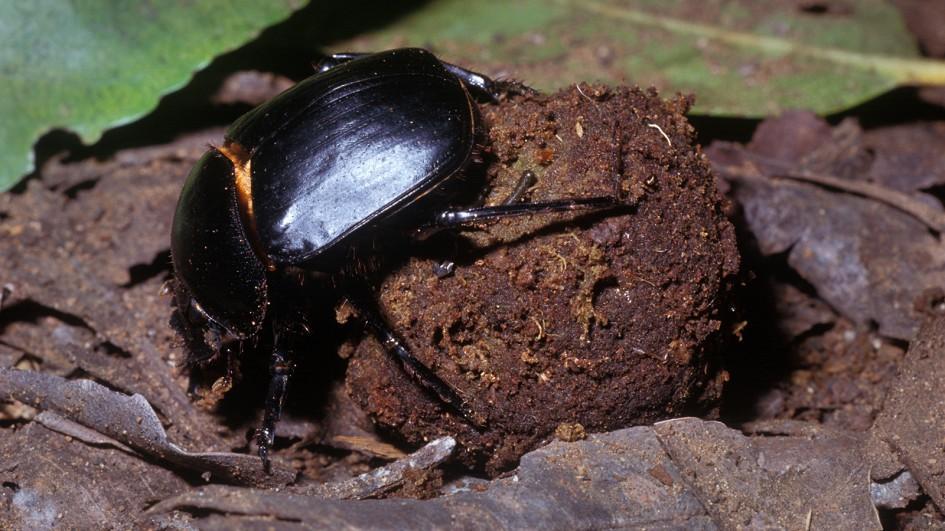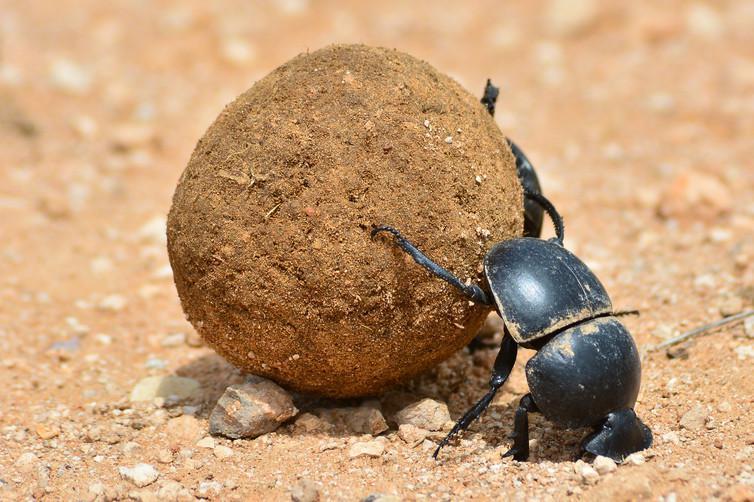The first image is the image on the left, the second image is the image on the right. Examine the images to the left and right. Is the description "Each image features a beetle in contact with a dung ball." accurate? Answer yes or no. Yes. The first image is the image on the left, the second image is the image on the right. Analyze the images presented: Is the assertion "Only one beetle is on a ball of dirt." valid? Answer yes or no. No. 